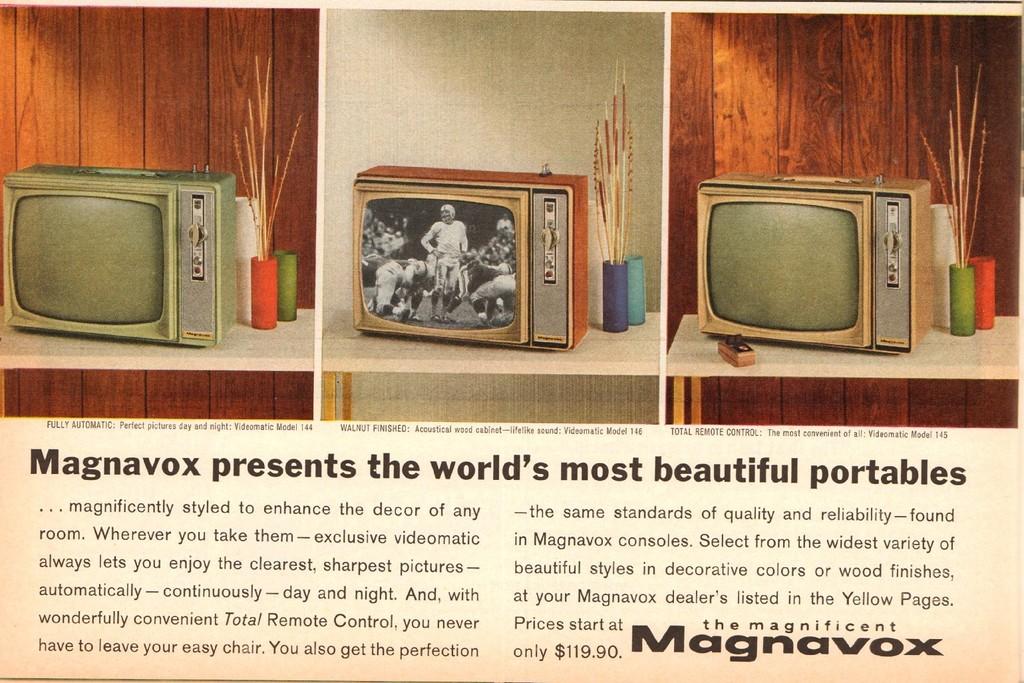Is this tv brand a magnavox?
Keep it short and to the point. Yes. 